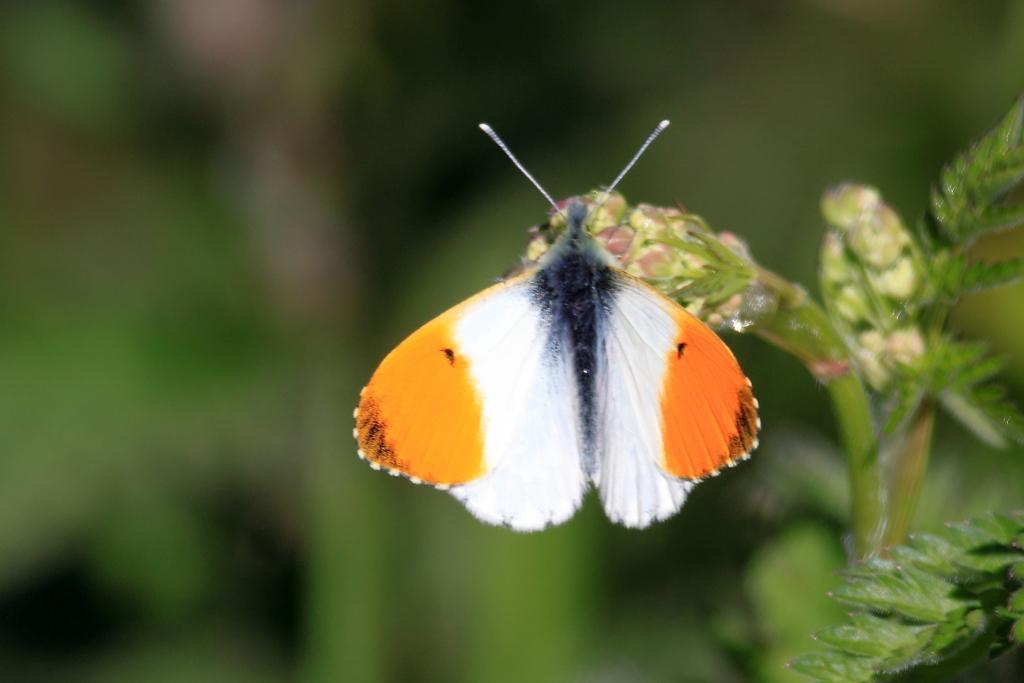Describe this image in one or two sentences. In this picture we can see a butterfly which is in the color of orange and white. And this is plant. 